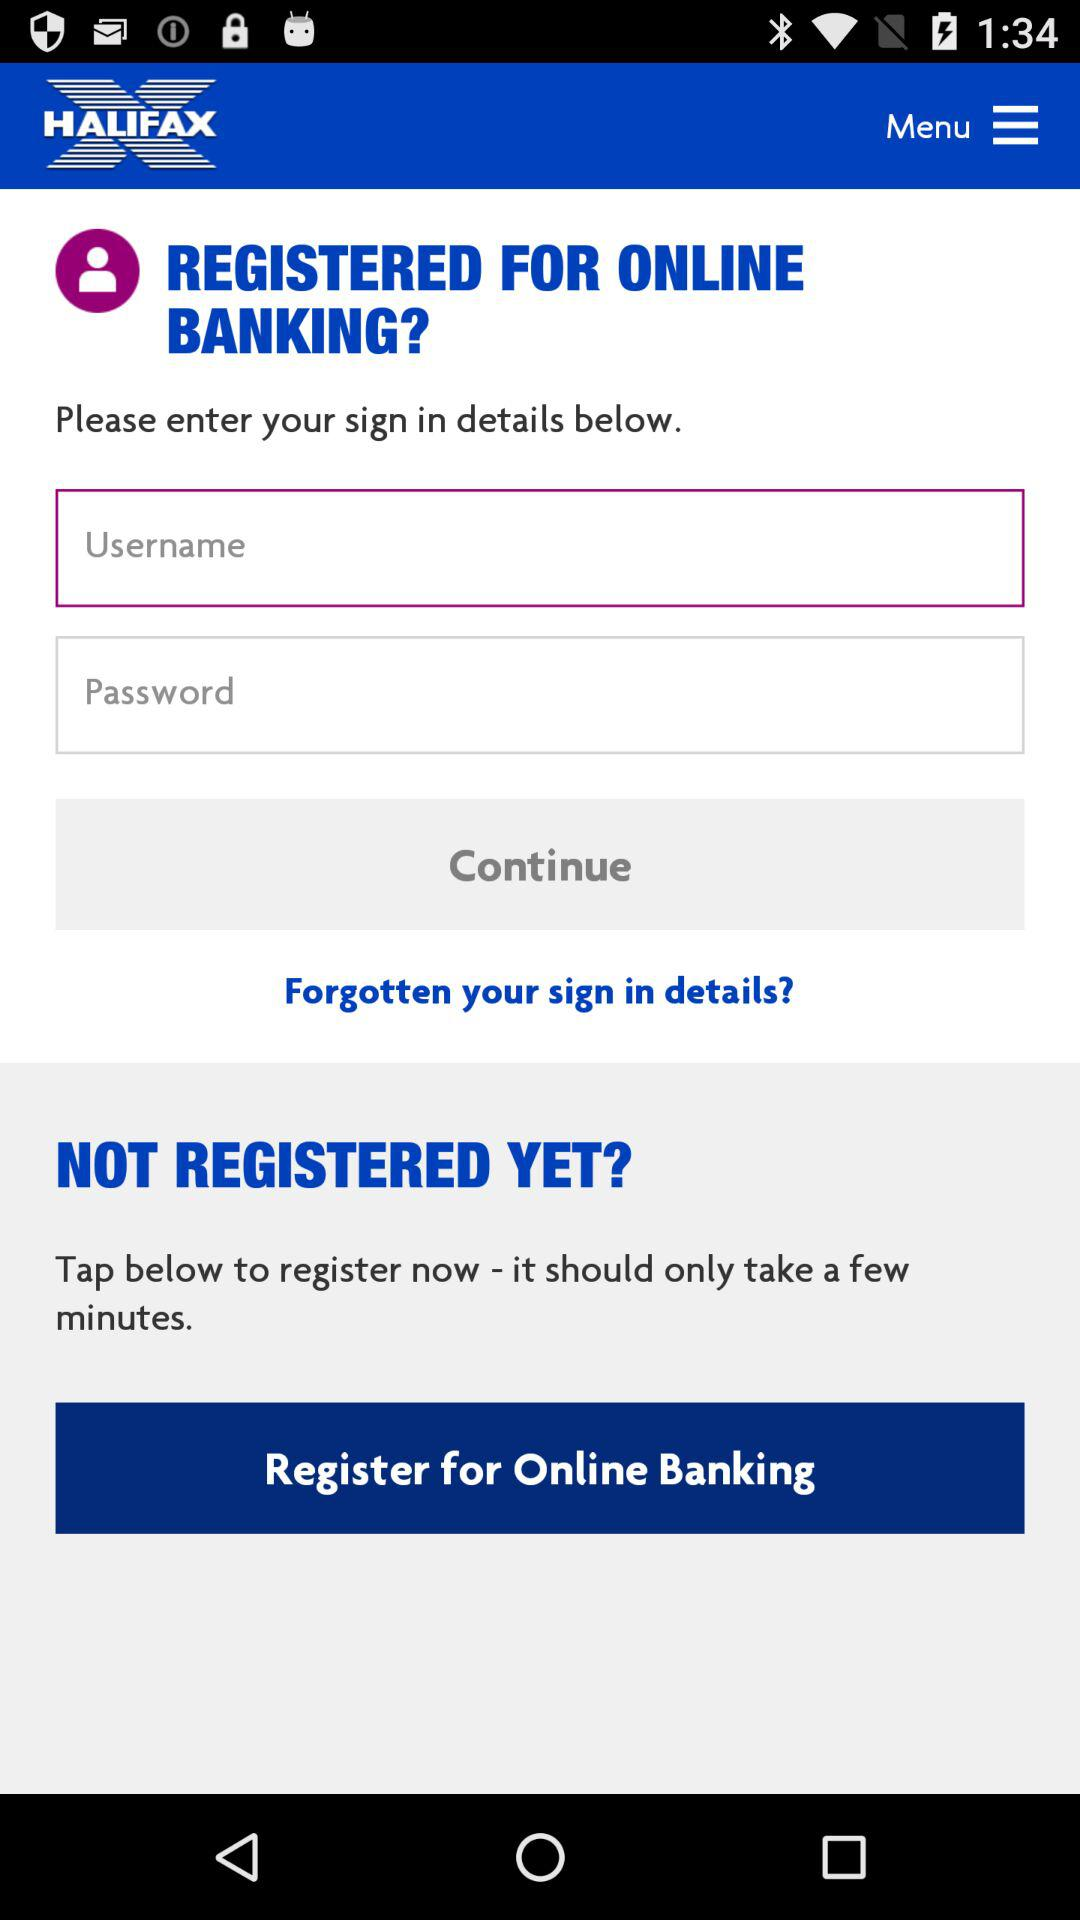How many fields are there for the user to enter their login details?
Answer the question using a single word or phrase. 2 